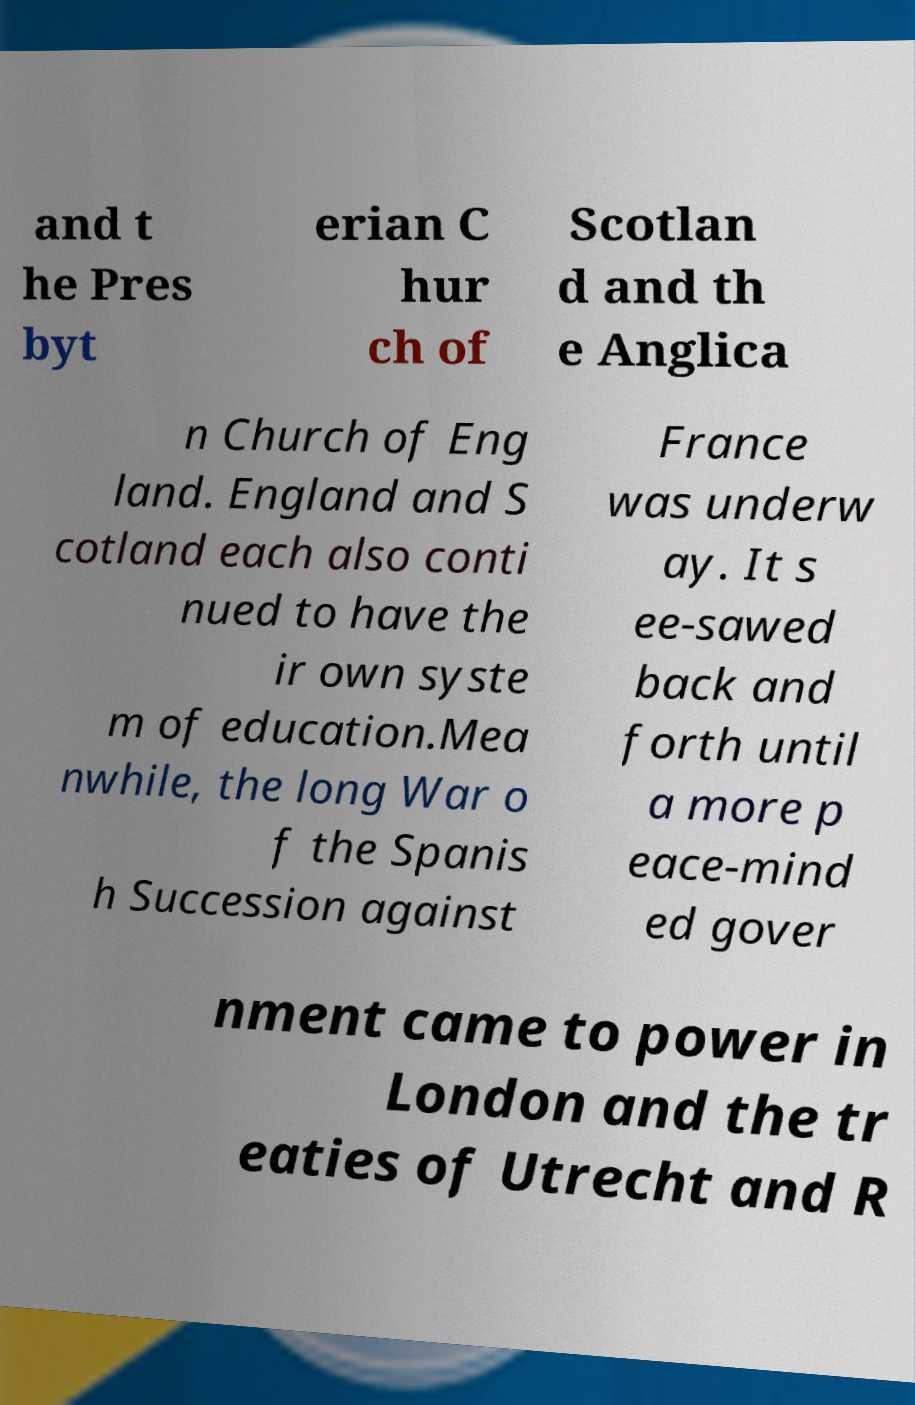Could you assist in decoding the text presented in this image and type it out clearly? and t he Pres byt erian C hur ch of Scotlan d and th e Anglica n Church of Eng land. England and S cotland each also conti nued to have the ir own syste m of education.Mea nwhile, the long War o f the Spanis h Succession against France was underw ay. It s ee-sawed back and forth until a more p eace-mind ed gover nment came to power in London and the tr eaties of Utrecht and R 